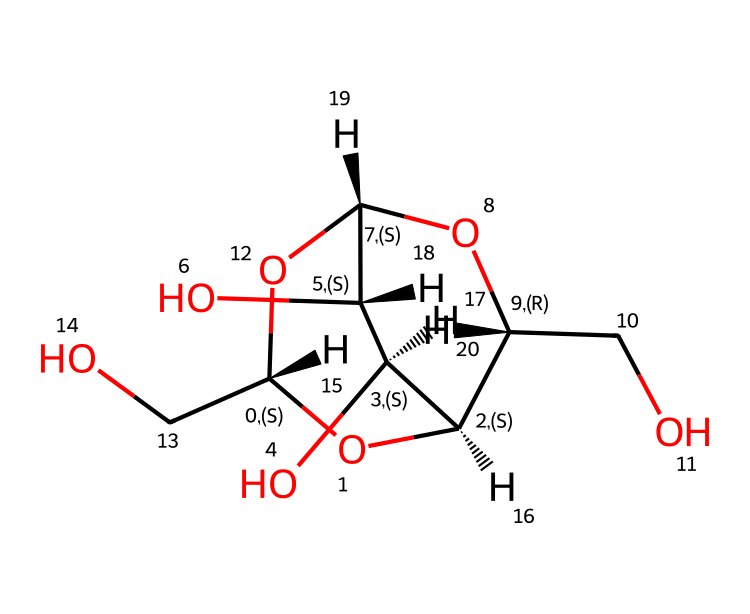What is the main type of molecule represented by this SMILES? The given SMILES represents a carbohydrate as it indicates a structure composed primarily of carbon, hydrogen, and oxygen, which is characteristic of sugars and polysaccharides.
Answer: carbohydrate How many carbon atoms are in the structure? By analyzing the SMILES, we can count the number of carbon atoms indicated by "C" in the structure. There are 6 carbon atoms present.
Answer: six What functional group is present in this chemical structure? The presence of the hydroxyl groups (-OH) can be deduced from the 'O' symbols attached to carbon atoms in the SMILES, indicating that the molecule has alcohol functional groups.
Answer: hydroxyl What makes cellulose different from other carbohydrates? Cellulose is composed of glucose units linked by β(1→4) glycosidic bonds, which gives it structural properties not found in simple sugars or starches. This structural organization is confirmed by the specific bonding arrangement in the SMILES.
Answer: structural rigidity How many oxygen atoms are in the chemical structure? Counting the 'O' notation in the SMILES gives a total of 6 oxygen atoms, making it clear how they are incorporated in the carbohydrate structure.
Answer: six What type of bonds connect the sugar units in cellulose? The SMILES indicates that the structure includes ether and glycosidic bonds connecting the glucose units, specifically through oxygen links, characteristic of cellulose.
Answer: glycosidic 